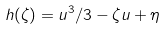<formula> <loc_0><loc_0><loc_500><loc_500>h ( \zeta ) = u ^ { 3 } / 3 - \zeta u + \eta</formula> 